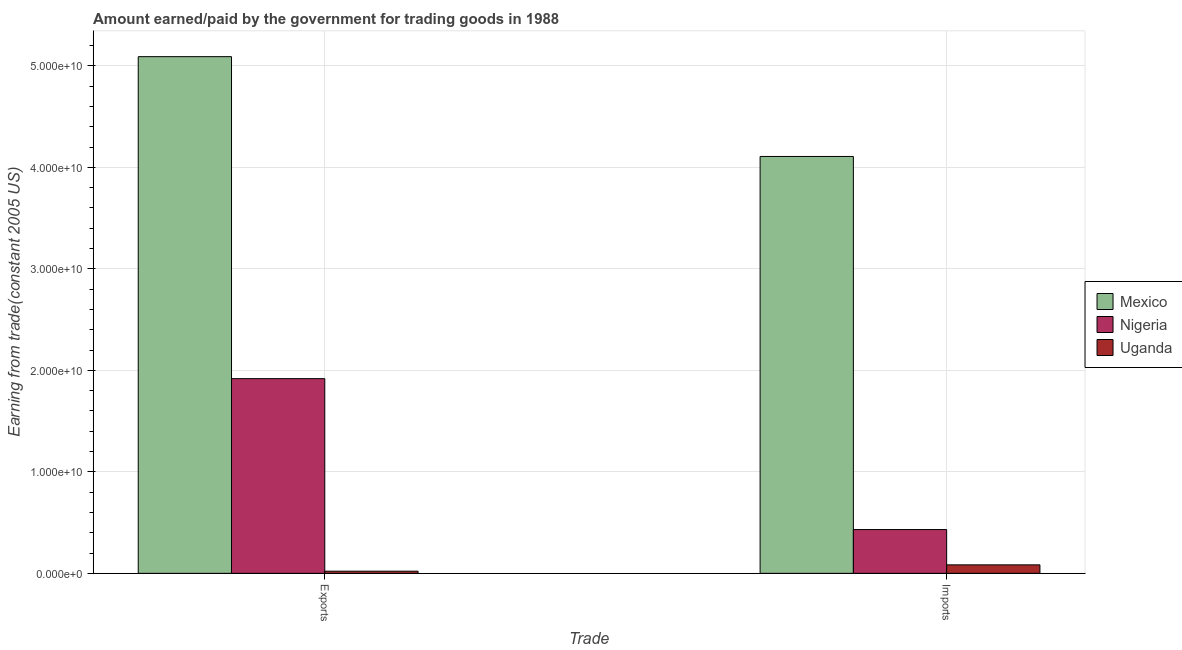How many different coloured bars are there?
Ensure brevity in your answer.  3. Are the number of bars per tick equal to the number of legend labels?
Your response must be concise. Yes. How many bars are there on the 2nd tick from the left?
Your response must be concise. 3. How many bars are there on the 1st tick from the right?
Your answer should be very brief. 3. What is the label of the 2nd group of bars from the left?
Offer a terse response. Imports. What is the amount earned from exports in Nigeria?
Ensure brevity in your answer.  1.92e+1. Across all countries, what is the maximum amount earned from exports?
Your response must be concise. 5.09e+1. Across all countries, what is the minimum amount paid for imports?
Provide a short and direct response. 8.35e+08. In which country was the amount earned from exports minimum?
Offer a terse response. Uganda. What is the total amount earned from exports in the graph?
Give a very brief answer. 7.03e+1. What is the difference between the amount paid for imports in Nigeria and that in Uganda?
Ensure brevity in your answer.  3.48e+09. What is the difference between the amount earned from exports in Nigeria and the amount paid for imports in Uganda?
Give a very brief answer. 1.83e+1. What is the average amount paid for imports per country?
Your answer should be very brief. 1.54e+1. What is the difference between the amount paid for imports and amount earned from exports in Nigeria?
Your response must be concise. -1.49e+1. In how many countries, is the amount paid for imports greater than 10000000000 US$?
Your answer should be very brief. 1. What is the ratio of the amount earned from exports in Uganda to that in Nigeria?
Provide a succinct answer. 0.01. In how many countries, is the amount earned from exports greater than the average amount earned from exports taken over all countries?
Provide a short and direct response. 1. What does the 2nd bar from the right in Imports represents?
Ensure brevity in your answer.  Nigeria. How many bars are there?
Ensure brevity in your answer.  6. What is the difference between two consecutive major ticks on the Y-axis?
Make the answer very short. 1.00e+1. Are the values on the major ticks of Y-axis written in scientific E-notation?
Make the answer very short. Yes. Does the graph contain any zero values?
Make the answer very short. No. Where does the legend appear in the graph?
Make the answer very short. Center right. How many legend labels are there?
Offer a very short reply. 3. How are the legend labels stacked?
Make the answer very short. Vertical. What is the title of the graph?
Keep it short and to the point. Amount earned/paid by the government for trading goods in 1988. What is the label or title of the X-axis?
Ensure brevity in your answer.  Trade. What is the label or title of the Y-axis?
Provide a short and direct response. Earning from trade(constant 2005 US). What is the Earning from trade(constant 2005 US) of Mexico in Exports?
Offer a terse response. 5.09e+1. What is the Earning from trade(constant 2005 US) of Nigeria in Exports?
Keep it short and to the point. 1.92e+1. What is the Earning from trade(constant 2005 US) in Uganda in Exports?
Give a very brief answer. 2.13e+08. What is the Earning from trade(constant 2005 US) of Mexico in Imports?
Your answer should be compact. 4.11e+1. What is the Earning from trade(constant 2005 US) of Nigeria in Imports?
Make the answer very short. 4.31e+09. What is the Earning from trade(constant 2005 US) in Uganda in Imports?
Offer a terse response. 8.35e+08. Across all Trade, what is the maximum Earning from trade(constant 2005 US) of Mexico?
Keep it short and to the point. 5.09e+1. Across all Trade, what is the maximum Earning from trade(constant 2005 US) in Nigeria?
Your answer should be compact. 1.92e+1. Across all Trade, what is the maximum Earning from trade(constant 2005 US) of Uganda?
Offer a terse response. 8.35e+08. Across all Trade, what is the minimum Earning from trade(constant 2005 US) of Mexico?
Your answer should be compact. 4.11e+1. Across all Trade, what is the minimum Earning from trade(constant 2005 US) of Nigeria?
Keep it short and to the point. 4.31e+09. Across all Trade, what is the minimum Earning from trade(constant 2005 US) of Uganda?
Your response must be concise. 2.13e+08. What is the total Earning from trade(constant 2005 US) in Mexico in the graph?
Your response must be concise. 9.20e+1. What is the total Earning from trade(constant 2005 US) in Nigeria in the graph?
Provide a succinct answer. 2.35e+1. What is the total Earning from trade(constant 2005 US) of Uganda in the graph?
Provide a short and direct response. 1.05e+09. What is the difference between the Earning from trade(constant 2005 US) in Mexico in Exports and that in Imports?
Your answer should be very brief. 9.83e+09. What is the difference between the Earning from trade(constant 2005 US) of Nigeria in Exports and that in Imports?
Keep it short and to the point. 1.49e+1. What is the difference between the Earning from trade(constant 2005 US) of Uganda in Exports and that in Imports?
Provide a short and direct response. -6.22e+08. What is the difference between the Earning from trade(constant 2005 US) of Mexico in Exports and the Earning from trade(constant 2005 US) of Nigeria in Imports?
Your answer should be very brief. 4.66e+1. What is the difference between the Earning from trade(constant 2005 US) of Mexico in Exports and the Earning from trade(constant 2005 US) of Uganda in Imports?
Provide a short and direct response. 5.01e+1. What is the difference between the Earning from trade(constant 2005 US) of Nigeria in Exports and the Earning from trade(constant 2005 US) of Uganda in Imports?
Your response must be concise. 1.83e+1. What is the average Earning from trade(constant 2005 US) of Mexico per Trade?
Ensure brevity in your answer.  4.60e+1. What is the average Earning from trade(constant 2005 US) in Nigeria per Trade?
Give a very brief answer. 1.17e+1. What is the average Earning from trade(constant 2005 US) in Uganda per Trade?
Offer a very short reply. 5.24e+08. What is the difference between the Earning from trade(constant 2005 US) in Mexico and Earning from trade(constant 2005 US) in Nigeria in Exports?
Provide a short and direct response. 3.17e+1. What is the difference between the Earning from trade(constant 2005 US) in Mexico and Earning from trade(constant 2005 US) in Uganda in Exports?
Offer a terse response. 5.07e+1. What is the difference between the Earning from trade(constant 2005 US) in Nigeria and Earning from trade(constant 2005 US) in Uganda in Exports?
Provide a succinct answer. 1.90e+1. What is the difference between the Earning from trade(constant 2005 US) in Mexico and Earning from trade(constant 2005 US) in Nigeria in Imports?
Your response must be concise. 3.68e+1. What is the difference between the Earning from trade(constant 2005 US) in Mexico and Earning from trade(constant 2005 US) in Uganda in Imports?
Your answer should be very brief. 4.02e+1. What is the difference between the Earning from trade(constant 2005 US) of Nigeria and Earning from trade(constant 2005 US) of Uganda in Imports?
Offer a terse response. 3.48e+09. What is the ratio of the Earning from trade(constant 2005 US) in Mexico in Exports to that in Imports?
Keep it short and to the point. 1.24. What is the ratio of the Earning from trade(constant 2005 US) of Nigeria in Exports to that in Imports?
Provide a short and direct response. 4.45. What is the ratio of the Earning from trade(constant 2005 US) in Uganda in Exports to that in Imports?
Make the answer very short. 0.25. What is the difference between the highest and the second highest Earning from trade(constant 2005 US) in Mexico?
Keep it short and to the point. 9.83e+09. What is the difference between the highest and the second highest Earning from trade(constant 2005 US) in Nigeria?
Keep it short and to the point. 1.49e+1. What is the difference between the highest and the second highest Earning from trade(constant 2005 US) of Uganda?
Your answer should be very brief. 6.22e+08. What is the difference between the highest and the lowest Earning from trade(constant 2005 US) in Mexico?
Ensure brevity in your answer.  9.83e+09. What is the difference between the highest and the lowest Earning from trade(constant 2005 US) of Nigeria?
Ensure brevity in your answer.  1.49e+1. What is the difference between the highest and the lowest Earning from trade(constant 2005 US) in Uganda?
Make the answer very short. 6.22e+08. 